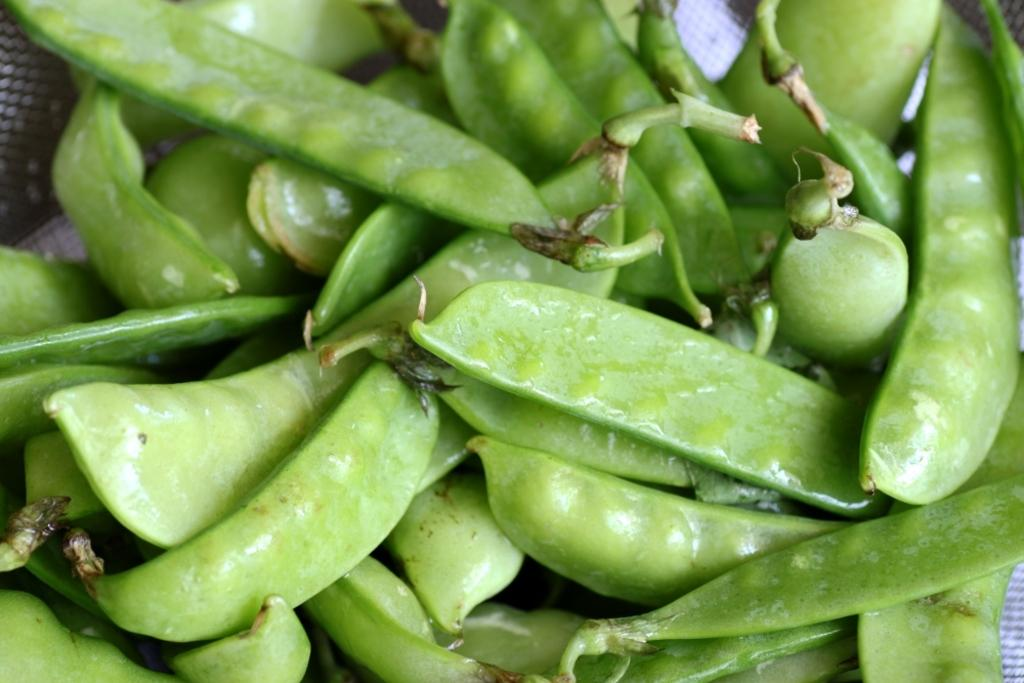What type of food is present in the image? There are beans in the image. Where are the beans located? The beans are on a table. What type of kitten is sitting on the beans in the image? There is no kitten present in the image; it only features beans on a table. 